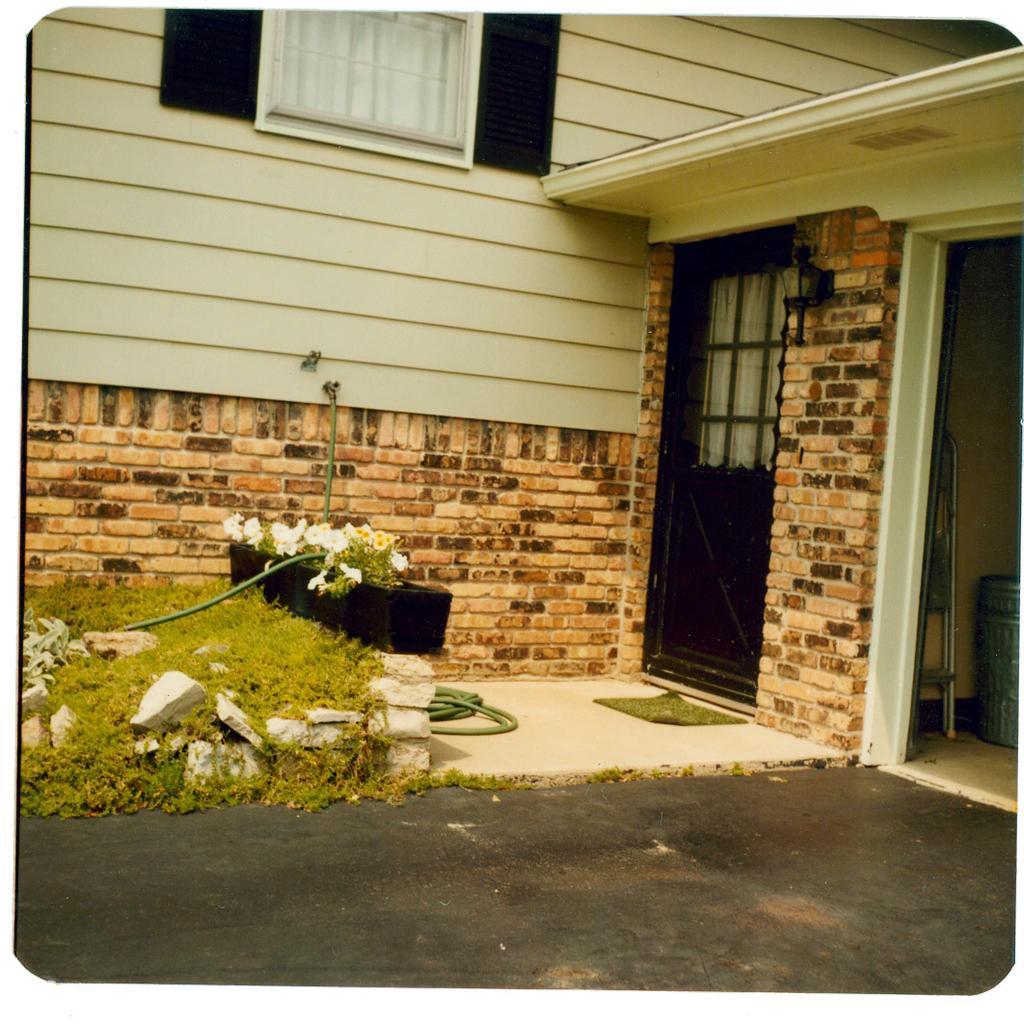Can you describe this image briefly? In this image we can see a building with windows and a door, in front the building there is a flower pot, there are some stones, grass, pipe and a mat. 